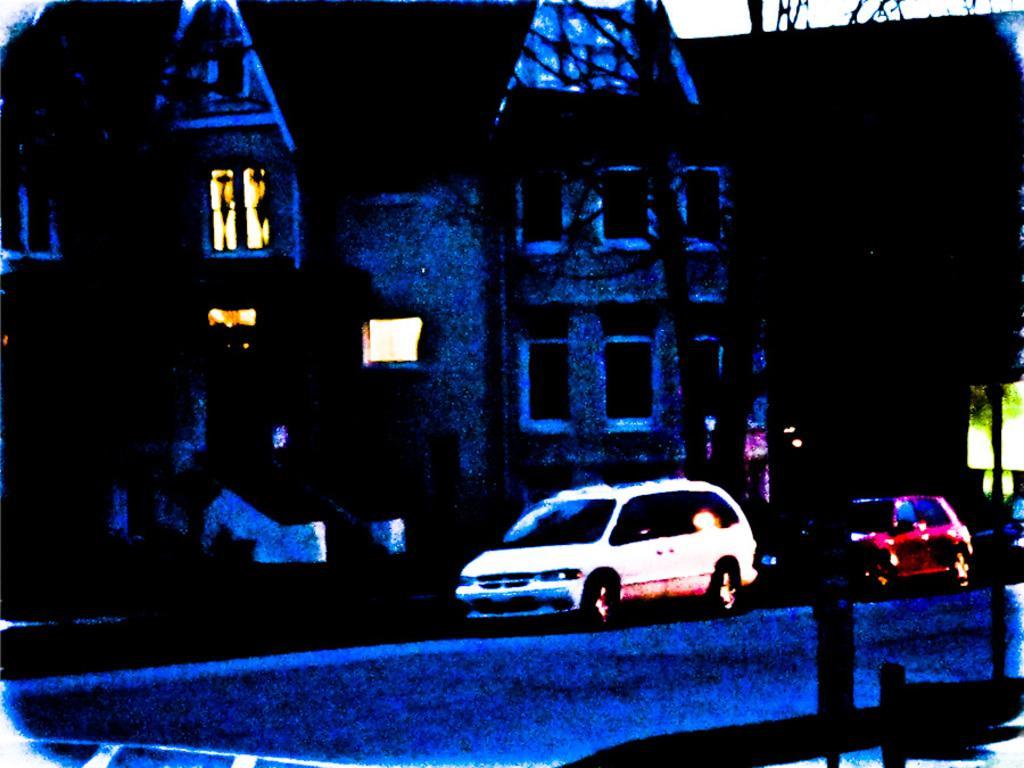Please provide a concise description of this image. In this image we can see buildings, pipelines, road and motor vehicles. 